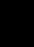Convert code to text. <code><loc_0><loc_0><loc_500><loc_500><_Java_>
</code> 